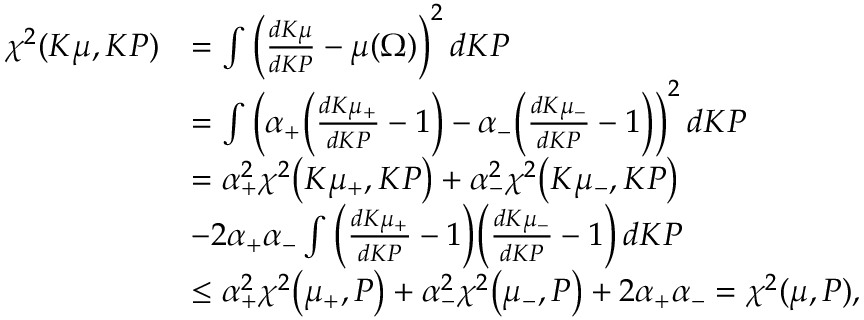<formula> <loc_0><loc_0><loc_500><loc_500>\begin{array} { r l } { \chi ^ { 2 } ( K \mu , K P ) } & { = \int \left ( \frac { d K \mu } { d K P } - \mu ( \Omega ) \right ) ^ { 2 } \, d K P } \\ & { = \int \left ( \alpha _ { + } \left ( \frac { d K \mu _ { + } } { d K P } - 1 \right ) - \alpha _ { - } \left ( \frac { d K \mu _ { - } } { d K P } - 1 \right ) \right ) ^ { 2 } \, d K P } \\ & { = \alpha _ { + } ^ { 2 } \chi ^ { 2 } \left ( K \mu _ { + } , K P \right ) + \alpha _ { - } ^ { 2 } \chi ^ { 2 } \left ( K \mu _ { - } , K P \right ) } \\ & { - 2 \alpha _ { + } \alpha _ { - } \int \left ( \frac { d K \mu _ { + } } { d K P } - 1 \right ) \left ( \frac { d K \mu _ { - } } { d K P } - 1 \right ) \, d K P } \\ & { \leq \alpha _ { + } ^ { 2 } \chi ^ { 2 } \left ( \mu _ { + } , P \right ) + \alpha _ { - } ^ { 2 } \chi ^ { 2 } \left ( \mu _ { - } , P \right ) + 2 \alpha _ { + } \alpha _ { - } = \chi ^ { 2 } ( \mu , P ) , } \end{array}</formula> 